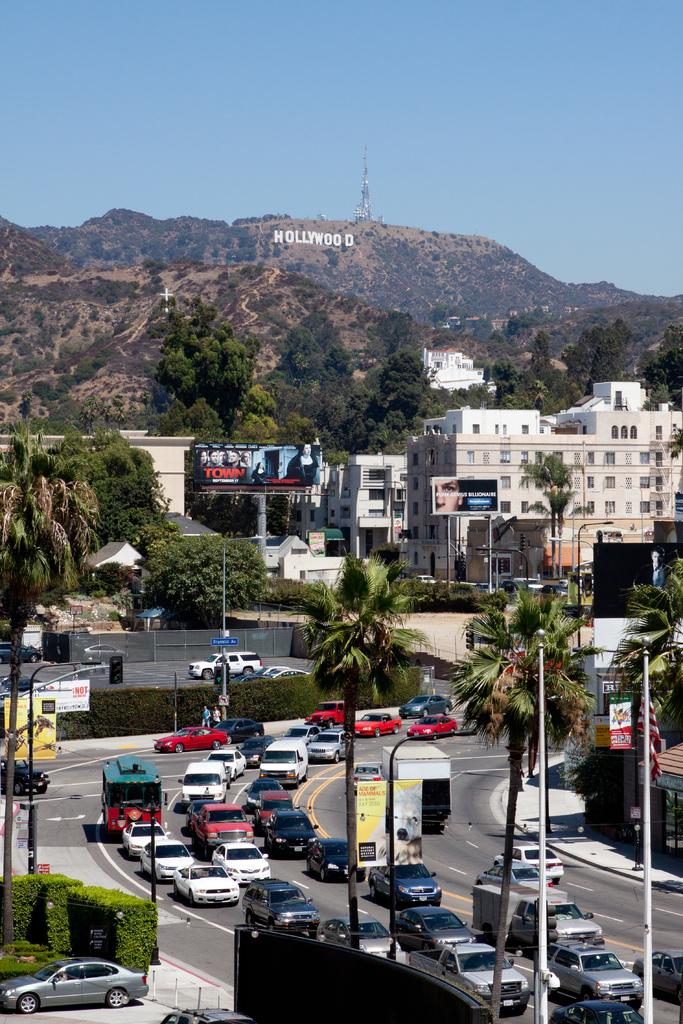What type of natural formation can be seen in the image? There are mountains in the image. What type of man-made structures are present in the image? There are buildings in the image. What type of vegetation is visible in the image? There are trees in the image. What type of vertical structures are present in the image? There are poles in the image. What type of transportation is visible in the image? Cars are moving on the road in the image. What type of agreement is being signed in the image? There is no agreement being signed in the image; it features mountains, buildings, trees, poles, and cars on the road. What type of machine is being used to create the buildings in the image? There is no machine visible in the image; it only shows the completed buildings. 